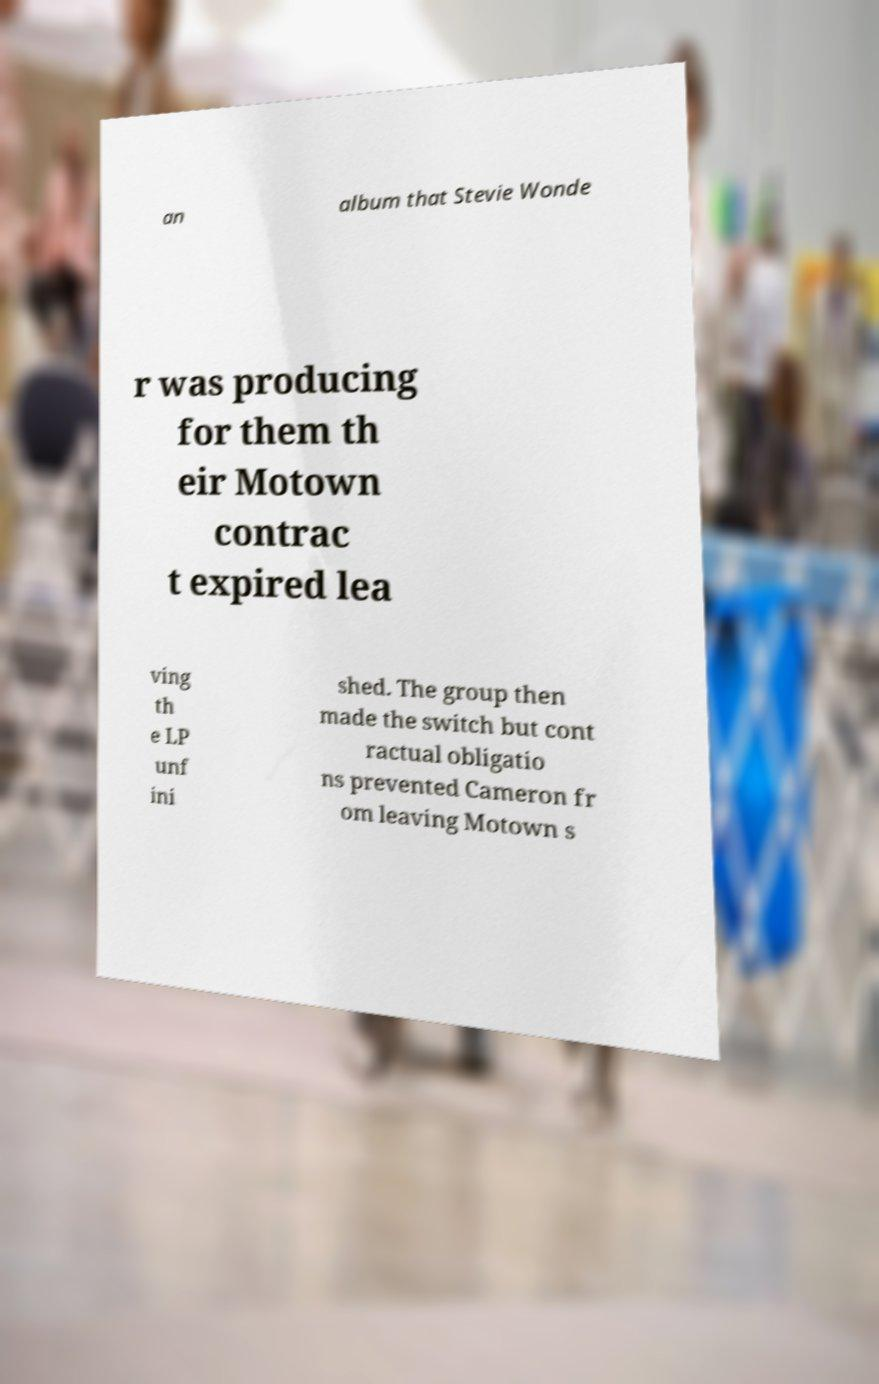What messages or text are displayed in this image? I need them in a readable, typed format. an album that Stevie Wonde r was producing for them th eir Motown contrac t expired lea ving th e LP unf ini shed. The group then made the switch but cont ractual obligatio ns prevented Cameron fr om leaving Motown s 